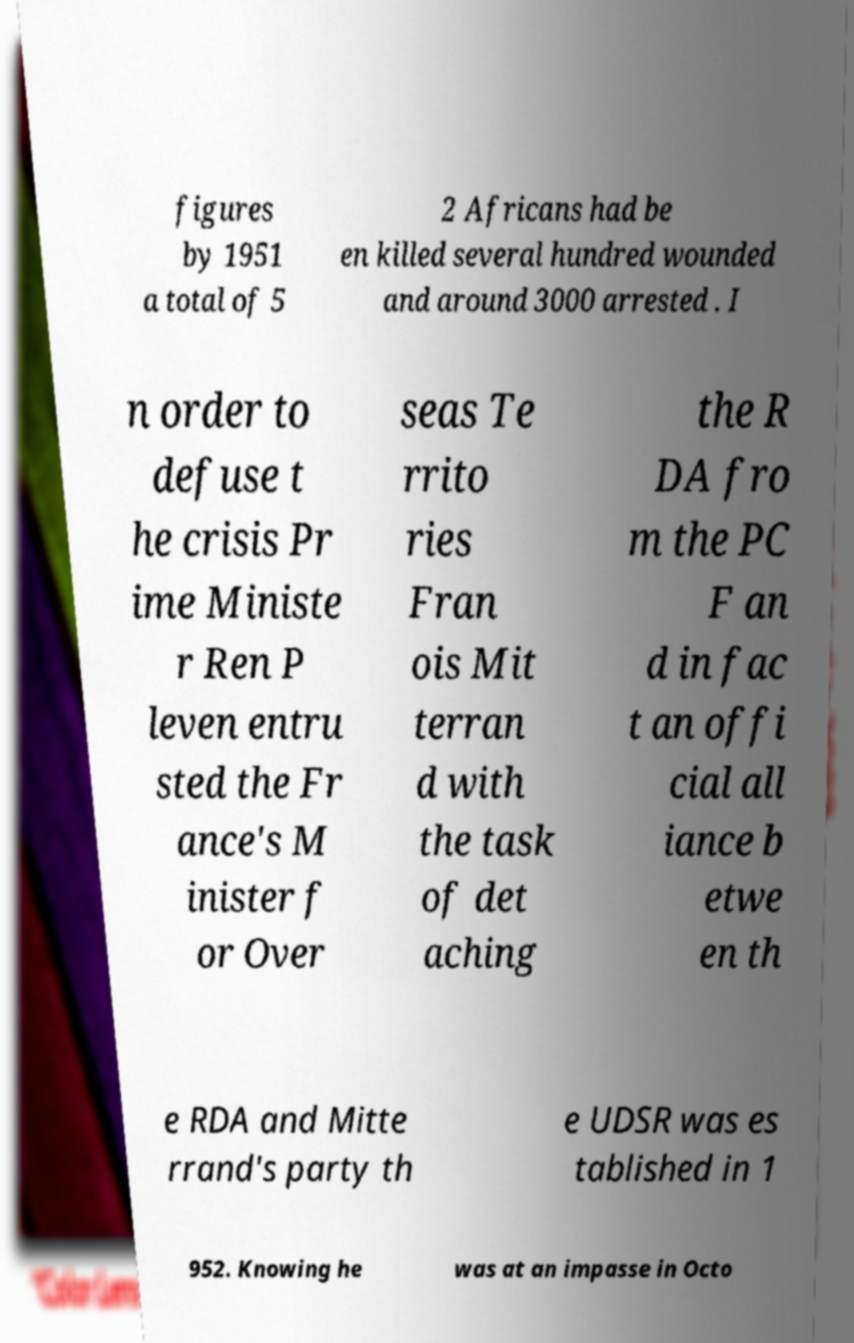What messages or text are displayed in this image? I need them in a readable, typed format. figures by 1951 a total of 5 2 Africans had be en killed several hundred wounded and around 3000 arrested . I n order to defuse t he crisis Pr ime Ministe r Ren P leven entru sted the Fr ance's M inister f or Over seas Te rrito ries Fran ois Mit terran d with the task of det aching the R DA fro m the PC F an d in fac t an offi cial all iance b etwe en th e RDA and Mitte rrand's party th e UDSR was es tablished in 1 952. Knowing he was at an impasse in Octo 